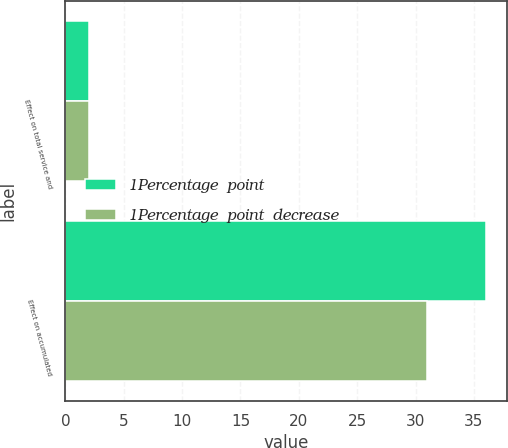<chart> <loc_0><loc_0><loc_500><loc_500><stacked_bar_chart><ecel><fcel>Effect on total service and<fcel>Effect on accumulated<nl><fcel>1Percentage  point<fcel>2<fcel>36<nl><fcel>1Percentage  point  decrease<fcel>2<fcel>31<nl></chart> 